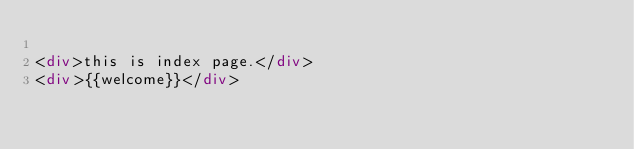<code> <loc_0><loc_0><loc_500><loc_500><_HTML_>
<div>this is index page.</div>
<div>{{welcome}}</div></code> 